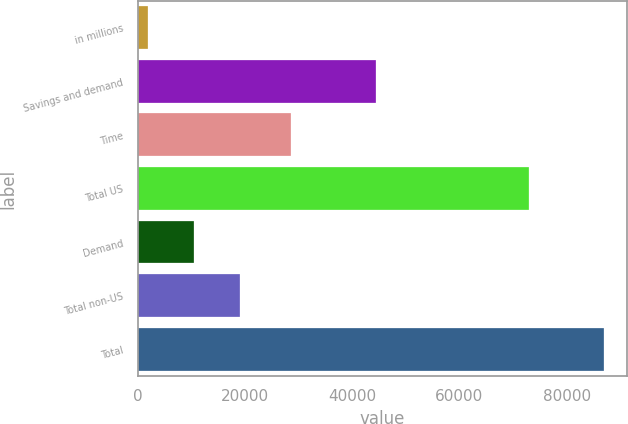Convert chart to OTSL. <chart><loc_0><loc_0><loc_500><loc_500><bar_chart><fcel>in millions<fcel>Savings and demand<fcel>Time<fcel>Total US<fcel>Demand<fcel>Total non-US<fcel>Total<nl><fcel>2015<fcel>44486<fcel>28577<fcel>73063<fcel>10508.3<fcel>19001.6<fcel>86948<nl></chart> 